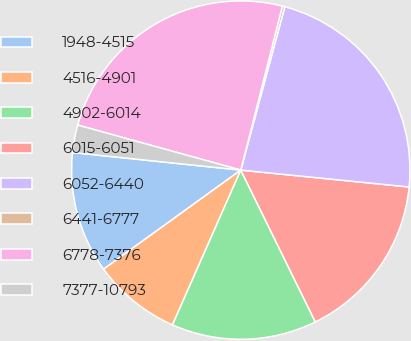<chart> <loc_0><loc_0><loc_500><loc_500><pie_chart><fcel>1948-4515<fcel>4516-4901<fcel>4902-6014<fcel>6015-6051<fcel>6052-6440<fcel>6441-6777<fcel>6778-7376<fcel>7377-10793<nl><fcel>11.61%<fcel>8.43%<fcel>13.88%<fcel>16.14%<fcel>22.4%<fcel>0.24%<fcel>24.66%<fcel>2.63%<nl></chart> 